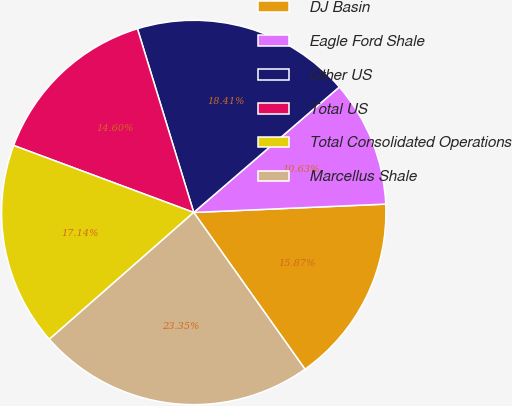Convert chart to OTSL. <chart><loc_0><loc_0><loc_500><loc_500><pie_chart><fcel>DJ Basin<fcel>Eagle Ford Shale<fcel>Other US<fcel>Total US<fcel>Total Consolidated Operations<fcel>Marcellus Shale<nl><fcel>15.87%<fcel>10.63%<fcel>18.41%<fcel>14.6%<fcel>17.14%<fcel>23.35%<nl></chart> 